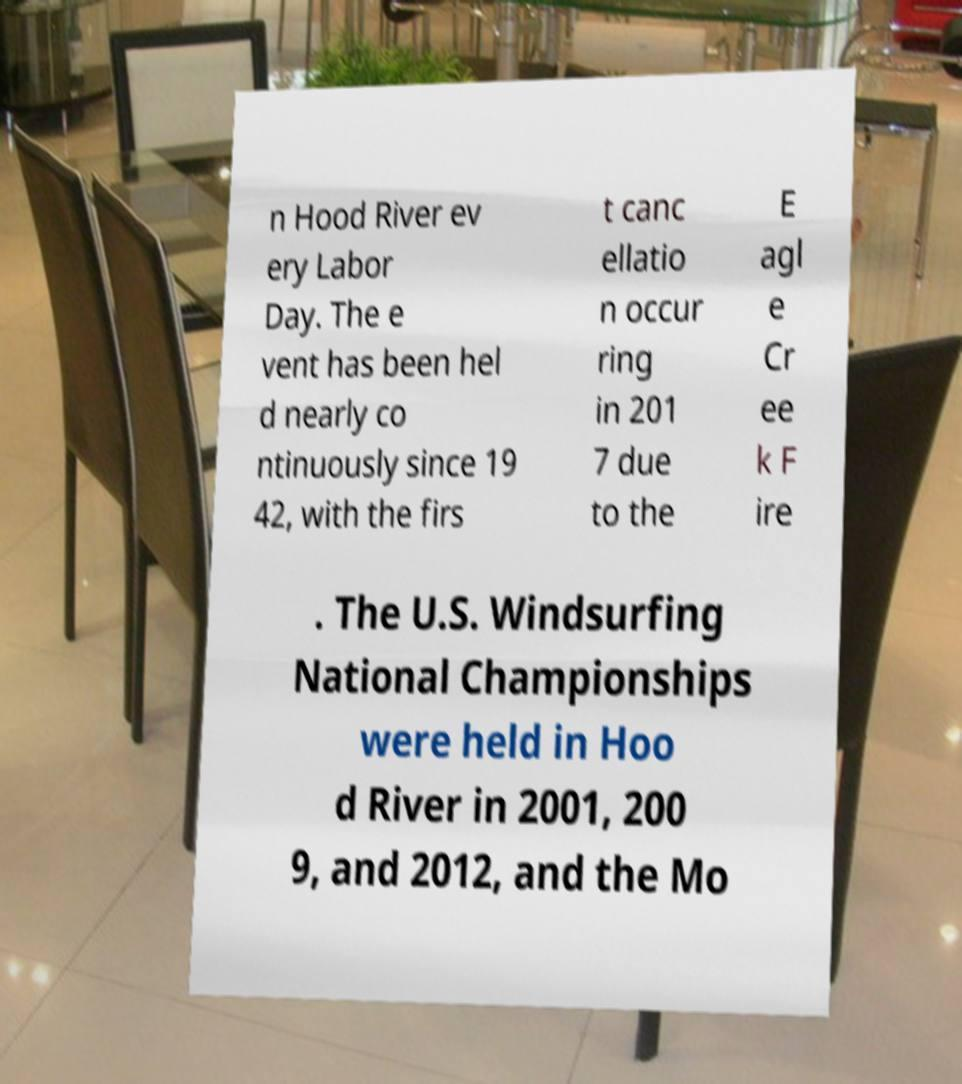Could you extract and type out the text from this image? n Hood River ev ery Labor Day. The e vent has been hel d nearly co ntinuously since 19 42, with the firs t canc ellatio n occur ring in 201 7 due to the E agl e Cr ee k F ire . The U.S. Windsurfing National Championships were held in Hoo d River in 2001, 200 9, and 2012, and the Mo 